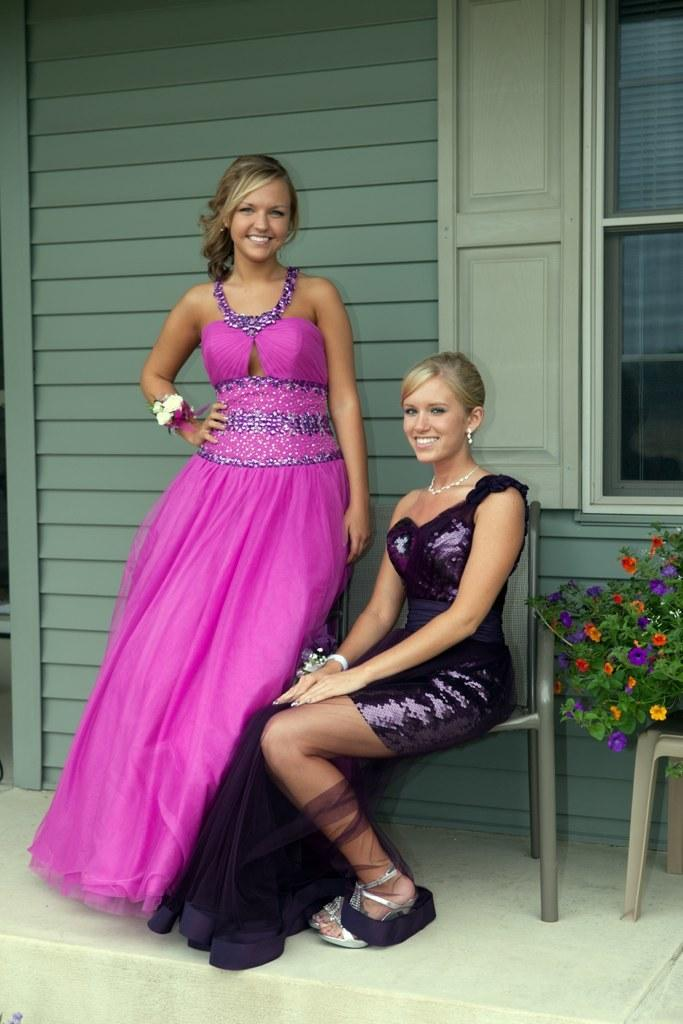What is the seated woman doing in the image? There is a woman sitting on a chair in the image. Who is with the seated woman? There is another woman standing beside the seated woman. What can be seen in the background of the image? There is a window on the wall in the background. What type of vegetation is present in the image? There are flowers on the plants in the image. What type of reaction can be seen from the oil in the image? There is no oil present in the image, so it is not possible to observe any reaction. 